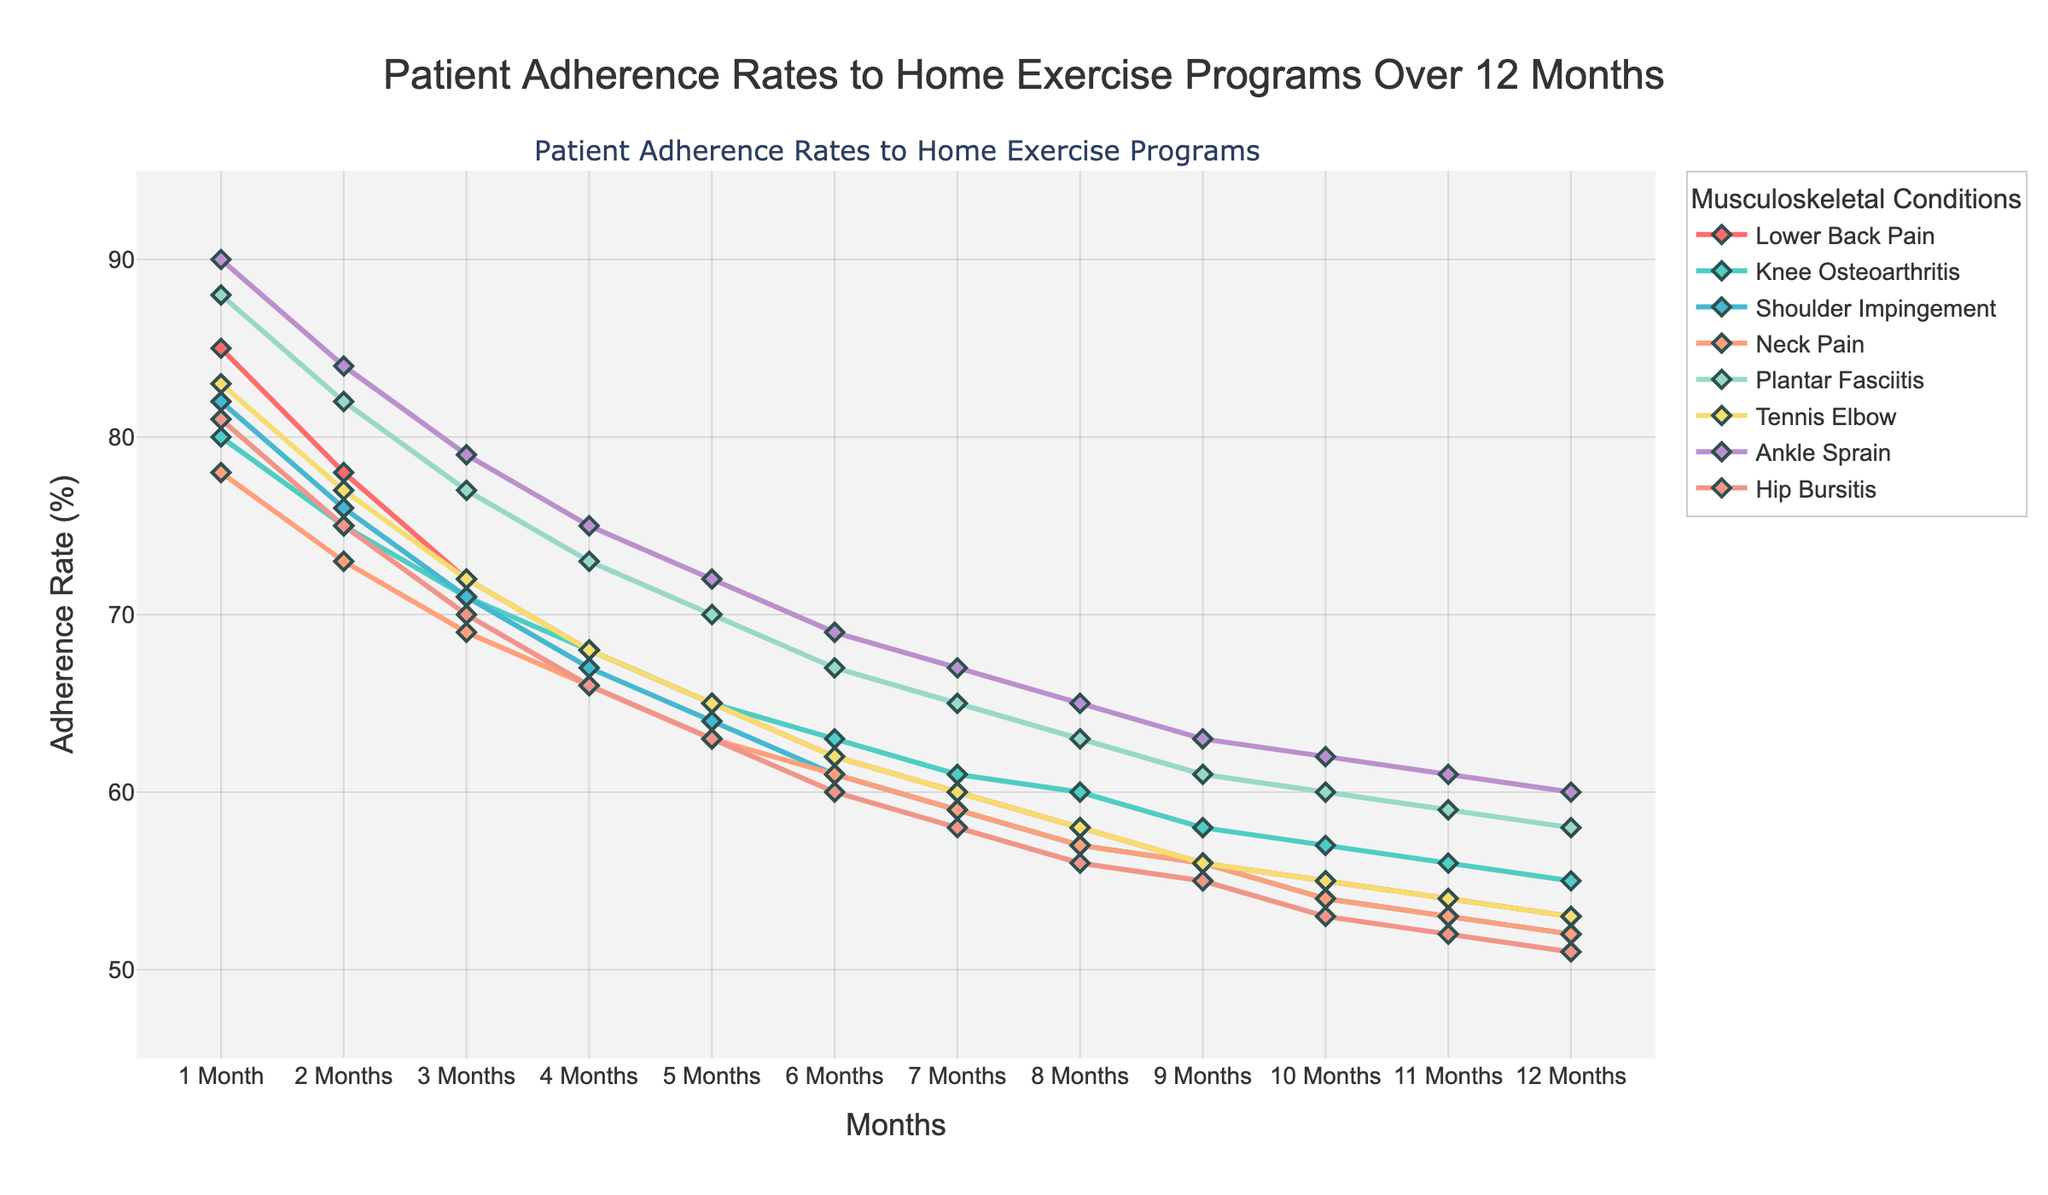What's the overall trend in adherence rates for Lower Back Pain over the 12 months? The adherence rate for Lower Back Pain starts at 85% in the first month and gradually declines to 53% by the twelfth month. Each month shows a slight decrease in adherence rate.
Answer: Declining Which condition has the highest adherence rate at the 6-month mark? At the 6-month mark, the adherence rates are as follows: Lower Back Pain (62%), Knee Osteoarthritis (63%), Shoulder Impingement (61%), Neck Pain (61%), Plantar Fasciitis (67%), Tennis Elbow (62%), Ankle Sprain (69%), and Hip Bursitis (60%). Ankle Sprain has the highest adherence rate.
Answer: Ankle Sprain Calculate the average adherence rate for Shoulder Impingement over the 12 months. The adherence rates for Shoulder Impingement across 12 months are: 82, 76, 71, 67, 64, 61, 59, 57, 56, 54, 53, 52. Sum these rates to get 752. Divide 752 by 12 to find the average. 752/12 = 62.67
Answer: 62.67 Which two conditions have the closest adherence rates at the 4-month mark? At the 4-month mark, the adherence rates are: Lower Back Pain (68%), Knee Osteoarthritis (68%), Shoulder Impingement (67%), Neck Pain (66%), Plantar Fasciitis (73%), Tennis Elbow (68%), Ankle Sprain (75%), and Hip Bursitis (66%). Lower Back Pain and Knee Osteoarthritis both have 68%.
Answer: Lower Back Pain and Knee Osteoarthritis Is there any condition whose adherence rate remains above 50% for all 12 months? Evaluating the adherence rates for all conditions across 12 months, Lower Back Pain (53%), Knee Osteoarthritis (55%), Shoulder Impingement (52%), Neck Pain (52%), Plantar Fasciitis (58%), Tennis Elbow (53%), Ankle Sprain (60%), Hip Bursitis (51%), Ankle Sprain's adherence rate remains above 50% for all months.
Answer: Ankle Sprain Compare the adherence rates of Plantar Fasciitis and Tennis Elbow at the 9-month mark and determine which is higher. At the 9-month mark, Plantar Fasciitis has an adherence rate of 61%, while Tennis Elbow has an adherence rate of 56%. Plantar Fasciitis has the higher adherence rate.
Answer: Plantar Fasciitis By how much does the adherence rate for Knee Osteoarthritis drop from the 1st month to the 12th month? The adherence rate for Knee Osteoarthritis is 80% in the 1st month and drops to 55% in the 12th month. The difference is 80 - 55 = 25%.
Answer: 25% Identify the condition with the least reduction in adherence rate from the 1st month to the 12th month. Calculating the reduction for each condition: 
Lower Back Pain (85-53=32), Knee Osteoarthritis (80-55=25), Shoulder Impingement (82-52=30), Neck Pain (78-52=26), Plantar Fasciitis (88-58=30), Tennis Elbow (83-53=30), Ankle Sprain (90-60=30), Hip Bursitis (81-51=30). 
Knee Osteoarthritis shows the least reduction at 25%.
Answer: Knee Osteoarthritis What is the difference in adherence rate between Ankle Sprain and Hip Bursitis at the 12-month mark? At the 12-month mark, Ankle Sprain has an adherence rate of 60%, and Hip Bursitis has 51%. The difference is 60 - 51 = 9%.
Answer: 9% What is the color of the line representing Tennis Elbow? Tennis Elbow is represented by a line with a visual color close to a shade of orange.
Answer: Orange 